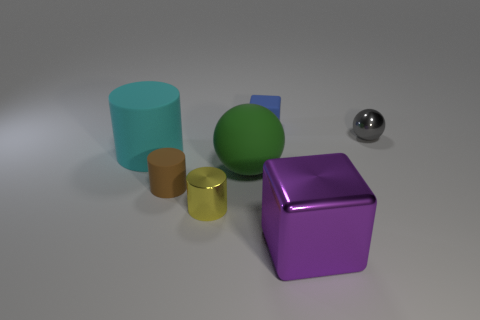Subtract all cyan cylinders. How many cylinders are left? 2 Add 2 gray metallic things. How many objects exist? 9 Subtract all yellow cylinders. How many cylinders are left? 2 Subtract 2 cylinders. How many cylinders are left? 1 Subtract 1 brown cylinders. How many objects are left? 6 Subtract all spheres. How many objects are left? 5 Subtract all brown cylinders. Subtract all gray spheres. How many cylinders are left? 2 Subtract all blue cubes. How many gray balls are left? 1 Subtract all tiny yellow rubber cylinders. Subtract all big green things. How many objects are left? 6 Add 6 cyan things. How many cyan things are left? 7 